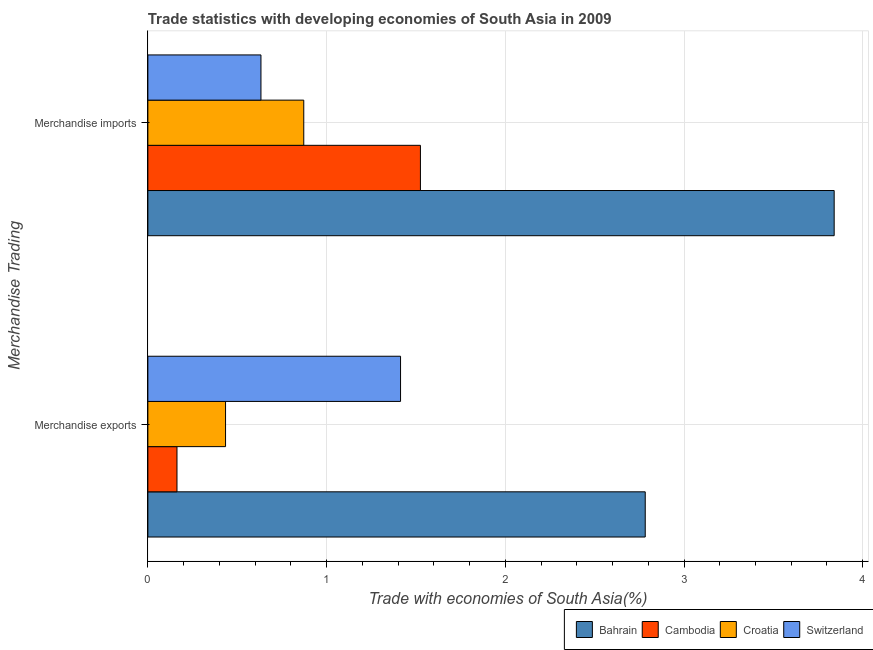How many different coloured bars are there?
Ensure brevity in your answer.  4. Are the number of bars on each tick of the Y-axis equal?
Your answer should be compact. Yes. What is the merchandise imports in Cambodia?
Offer a terse response. 1.53. Across all countries, what is the maximum merchandise exports?
Provide a short and direct response. 2.78. Across all countries, what is the minimum merchandise exports?
Your answer should be compact. 0.16. In which country was the merchandise imports maximum?
Provide a succinct answer. Bahrain. In which country was the merchandise imports minimum?
Make the answer very short. Switzerland. What is the total merchandise exports in the graph?
Provide a succinct answer. 4.79. What is the difference between the merchandise imports in Croatia and that in Cambodia?
Your answer should be compact. -0.65. What is the difference between the merchandise exports in Bahrain and the merchandise imports in Cambodia?
Ensure brevity in your answer.  1.26. What is the average merchandise exports per country?
Ensure brevity in your answer.  1.2. What is the difference between the merchandise exports and merchandise imports in Bahrain?
Provide a succinct answer. -1.06. In how many countries, is the merchandise exports greater than 0.6000000000000001 %?
Provide a succinct answer. 2. What is the ratio of the merchandise imports in Croatia to that in Cambodia?
Make the answer very short. 0.57. What does the 3rd bar from the top in Merchandise imports represents?
Offer a very short reply. Cambodia. What does the 1st bar from the bottom in Merchandise imports represents?
Offer a terse response. Bahrain. Are all the bars in the graph horizontal?
Ensure brevity in your answer.  Yes. How many legend labels are there?
Your answer should be very brief. 4. How are the legend labels stacked?
Keep it short and to the point. Horizontal. What is the title of the graph?
Your answer should be very brief. Trade statistics with developing economies of South Asia in 2009. What is the label or title of the X-axis?
Offer a terse response. Trade with economies of South Asia(%). What is the label or title of the Y-axis?
Keep it short and to the point. Merchandise Trading. What is the Trade with economies of South Asia(%) of Bahrain in Merchandise exports?
Offer a terse response. 2.78. What is the Trade with economies of South Asia(%) of Cambodia in Merchandise exports?
Keep it short and to the point. 0.16. What is the Trade with economies of South Asia(%) in Croatia in Merchandise exports?
Your answer should be compact. 0.43. What is the Trade with economies of South Asia(%) of Switzerland in Merchandise exports?
Offer a terse response. 1.41. What is the Trade with economies of South Asia(%) of Bahrain in Merchandise imports?
Your answer should be compact. 3.84. What is the Trade with economies of South Asia(%) of Cambodia in Merchandise imports?
Offer a terse response. 1.53. What is the Trade with economies of South Asia(%) in Croatia in Merchandise imports?
Your answer should be very brief. 0.87. What is the Trade with economies of South Asia(%) in Switzerland in Merchandise imports?
Make the answer very short. 0.63. Across all Merchandise Trading, what is the maximum Trade with economies of South Asia(%) of Bahrain?
Offer a terse response. 3.84. Across all Merchandise Trading, what is the maximum Trade with economies of South Asia(%) of Cambodia?
Keep it short and to the point. 1.53. Across all Merchandise Trading, what is the maximum Trade with economies of South Asia(%) of Croatia?
Your answer should be very brief. 0.87. Across all Merchandise Trading, what is the maximum Trade with economies of South Asia(%) in Switzerland?
Provide a succinct answer. 1.41. Across all Merchandise Trading, what is the minimum Trade with economies of South Asia(%) of Bahrain?
Keep it short and to the point. 2.78. Across all Merchandise Trading, what is the minimum Trade with economies of South Asia(%) in Cambodia?
Make the answer very short. 0.16. Across all Merchandise Trading, what is the minimum Trade with economies of South Asia(%) in Croatia?
Your response must be concise. 0.43. Across all Merchandise Trading, what is the minimum Trade with economies of South Asia(%) in Switzerland?
Give a very brief answer. 0.63. What is the total Trade with economies of South Asia(%) in Bahrain in the graph?
Your response must be concise. 6.62. What is the total Trade with economies of South Asia(%) of Cambodia in the graph?
Keep it short and to the point. 1.69. What is the total Trade with economies of South Asia(%) in Croatia in the graph?
Make the answer very short. 1.31. What is the total Trade with economies of South Asia(%) in Switzerland in the graph?
Your answer should be compact. 2.05. What is the difference between the Trade with economies of South Asia(%) of Bahrain in Merchandise exports and that in Merchandise imports?
Ensure brevity in your answer.  -1.06. What is the difference between the Trade with economies of South Asia(%) of Cambodia in Merchandise exports and that in Merchandise imports?
Provide a succinct answer. -1.36. What is the difference between the Trade with economies of South Asia(%) of Croatia in Merchandise exports and that in Merchandise imports?
Your answer should be compact. -0.44. What is the difference between the Trade with economies of South Asia(%) of Switzerland in Merchandise exports and that in Merchandise imports?
Your answer should be compact. 0.78. What is the difference between the Trade with economies of South Asia(%) in Bahrain in Merchandise exports and the Trade with economies of South Asia(%) in Cambodia in Merchandise imports?
Your answer should be very brief. 1.26. What is the difference between the Trade with economies of South Asia(%) of Bahrain in Merchandise exports and the Trade with economies of South Asia(%) of Croatia in Merchandise imports?
Your response must be concise. 1.91. What is the difference between the Trade with economies of South Asia(%) of Bahrain in Merchandise exports and the Trade with economies of South Asia(%) of Switzerland in Merchandise imports?
Give a very brief answer. 2.15. What is the difference between the Trade with economies of South Asia(%) of Cambodia in Merchandise exports and the Trade with economies of South Asia(%) of Croatia in Merchandise imports?
Provide a short and direct response. -0.71. What is the difference between the Trade with economies of South Asia(%) of Cambodia in Merchandise exports and the Trade with economies of South Asia(%) of Switzerland in Merchandise imports?
Your response must be concise. -0.47. What is the difference between the Trade with economies of South Asia(%) of Croatia in Merchandise exports and the Trade with economies of South Asia(%) of Switzerland in Merchandise imports?
Give a very brief answer. -0.2. What is the average Trade with economies of South Asia(%) of Bahrain per Merchandise Trading?
Offer a terse response. 3.31. What is the average Trade with economies of South Asia(%) in Cambodia per Merchandise Trading?
Provide a short and direct response. 0.84. What is the average Trade with economies of South Asia(%) in Croatia per Merchandise Trading?
Keep it short and to the point. 0.65. What is the average Trade with economies of South Asia(%) of Switzerland per Merchandise Trading?
Your answer should be very brief. 1.02. What is the difference between the Trade with economies of South Asia(%) of Bahrain and Trade with economies of South Asia(%) of Cambodia in Merchandise exports?
Your response must be concise. 2.62. What is the difference between the Trade with economies of South Asia(%) in Bahrain and Trade with economies of South Asia(%) in Croatia in Merchandise exports?
Make the answer very short. 2.35. What is the difference between the Trade with economies of South Asia(%) of Bahrain and Trade with economies of South Asia(%) of Switzerland in Merchandise exports?
Your response must be concise. 1.37. What is the difference between the Trade with economies of South Asia(%) of Cambodia and Trade with economies of South Asia(%) of Croatia in Merchandise exports?
Your answer should be compact. -0.27. What is the difference between the Trade with economies of South Asia(%) of Cambodia and Trade with economies of South Asia(%) of Switzerland in Merchandise exports?
Your response must be concise. -1.25. What is the difference between the Trade with economies of South Asia(%) in Croatia and Trade with economies of South Asia(%) in Switzerland in Merchandise exports?
Offer a terse response. -0.98. What is the difference between the Trade with economies of South Asia(%) in Bahrain and Trade with economies of South Asia(%) in Cambodia in Merchandise imports?
Offer a very short reply. 2.32. What is the difference between the Trade with economies of South Asia(%) in Bahrain and Trade with economies of South Asia(%) in Croatia in Merchandise imports?
Your answer should be compact. 2.97. What is the difference between the Trade with economies of South Asia(%) of Bahrain and Trade with economies of South Asia(%) of Switzerland in Merchandise imports?
Make the answer very short. 3.21. What is the difference between the Trade with economies of South Asia(%) in Cambodia and Trade with economies of South Asia(%) in Croatia in Merchandise imports?
Provide a short and direct response. 0.65. What is the difference between the Trade with economies of South Asia(%) of Cambodia and Trade with economies of South Asia(%) of Switzerland in Merchandise imports?
Your response must be concise. 0.89. What is the difference between the Trade with economies of South Asia(%) of Croatia and Trade with economies of South Asia(%) of Switzerland in Merchandise imports?
Your answer should be very brief. 0.24. What is the ratio of the Trade with economies of South Asia(%) of Bahrain in Merchandise exports to that in Merchandise imports?
Your answer should be compact. 0.72. What is the ratio of the Trade with economies of South Asia(%) in Cambodia in Merchandise exports to that in Merchandise imports?
Your response must be concise. 0.11. What is the ratio of the Trade with economies of South Asia(%) in Croatia in Merchandise exports to that in Merchandise imports?
Make the answer very short. 0.5. What is the ratio of the Trade with economies of South Asia(%) of Switzerland in Merchandise exports to that in Merchandise imports?
Ensure brevity in your answer.  2.23. What is the difference between the highest and the second highest Trade with economies of South Asia(%) of Bahrain?
Provide a succinct answer. 1.06. What is the difference between the highest and the second highest Trade with economies of South Asia(%) of Cambodia?
Provide a short and direct response. 1.36. What is the difference between the highest and the second highest Trade with economies of South Asia(%) of Croatia?
Offer a very short reply. 0.44. What is the difference between the highest and the second highest Trade with economies of South Asia(%) in Switzerland?
Keep it short and to the point. 0.78. What is the difference between the highest and the lowest Trade with economies of South Asia(%) of Bahrain?
Give a very brief answer. 1.06. What is the difference between the highest and the lowest Trade with economies of South Asia(%) of Cambodia?
Keep it short and to the point. 1.36. What is the difference between the highest and the lowest Trade with economies of South Asia(%) of Croatia?
Make the answer very short. 0.44. What is the difference between the highest and the lowest Trade with economies of South Asia(%) in Switzerland?
Provide a succinct answer. 0.78. 